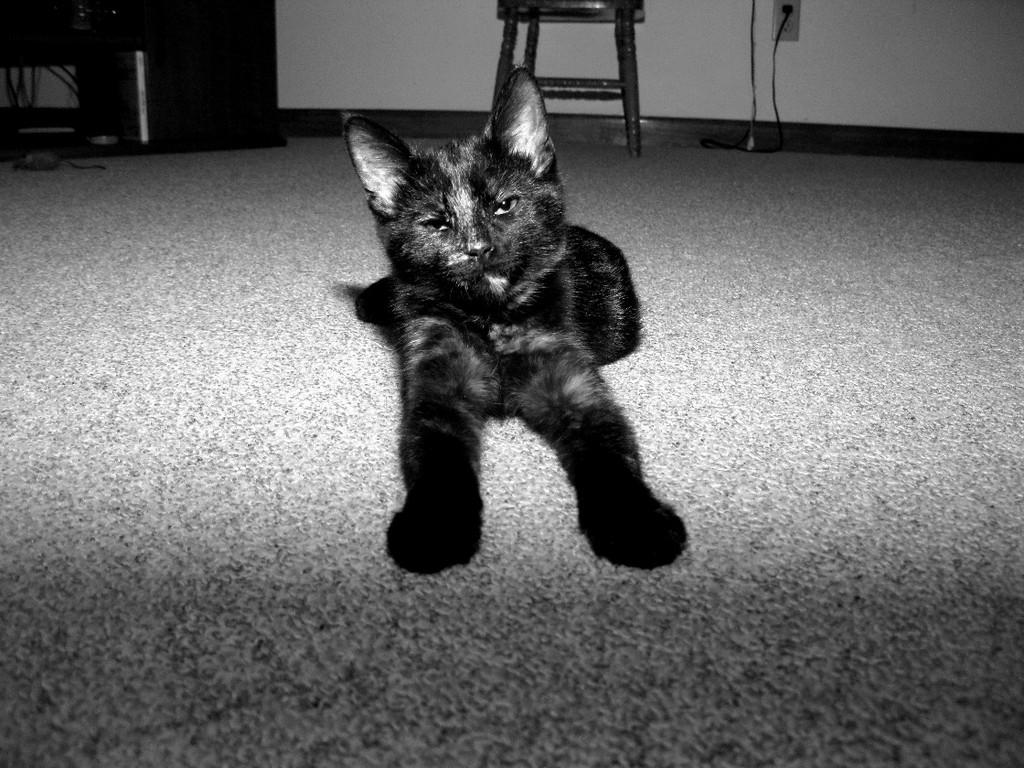What type of animal is in the image? There is a cat in the image. What can be seen on the left side of the image? There are objects on the left side of the image. What piece of furniture is in the image? There is a chair in the image. What electrical connection is visible in the image? A plug is plugged into a socket in the image. What year is depicted in the image? The image does not depict a specific year; it is a static representation of the objects and elements mentioned in the facts. 